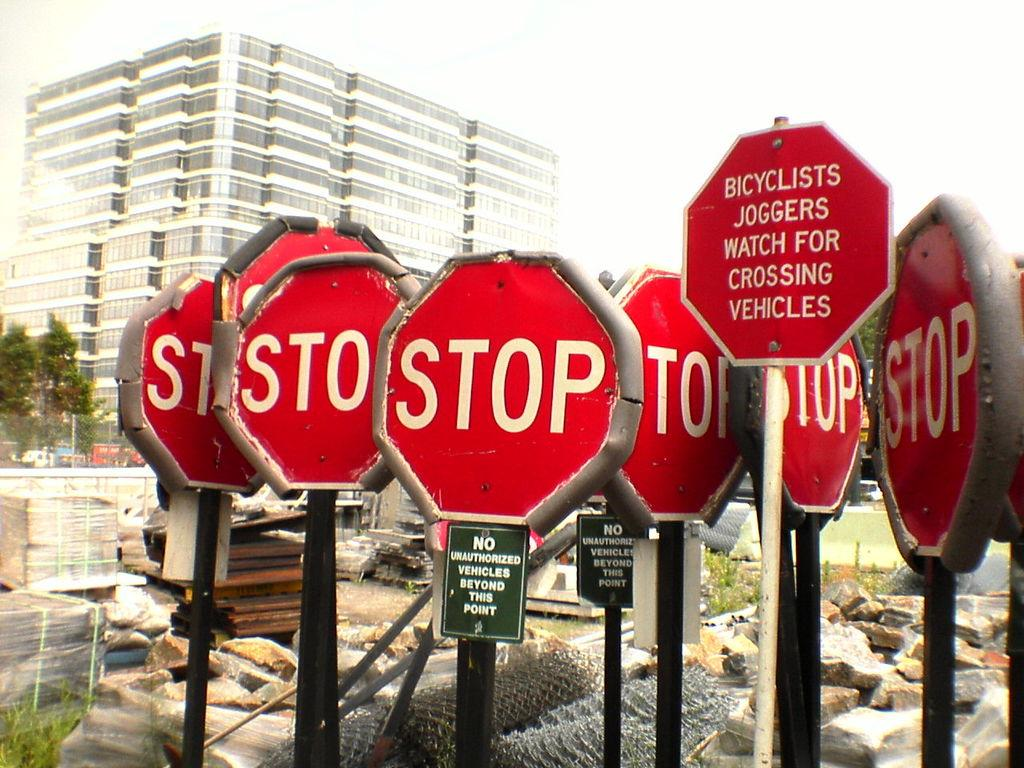<image>
Provide a brief description of the given image. many stop signs are among each other outside 